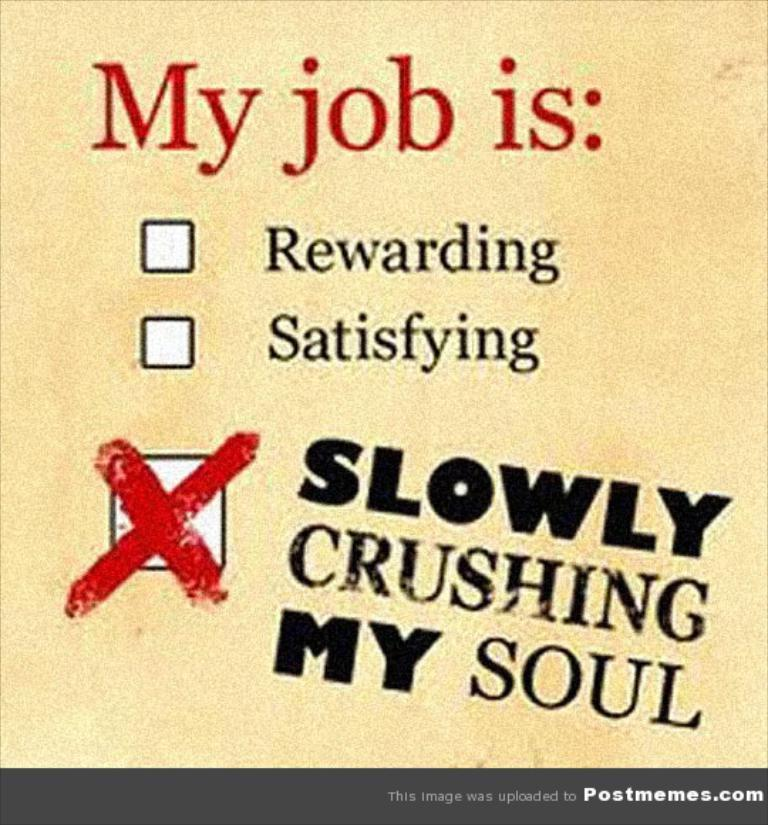<image>
Summarize the visual content of the image. A meme post expressing a person's extreme dissatisfaction with their job 